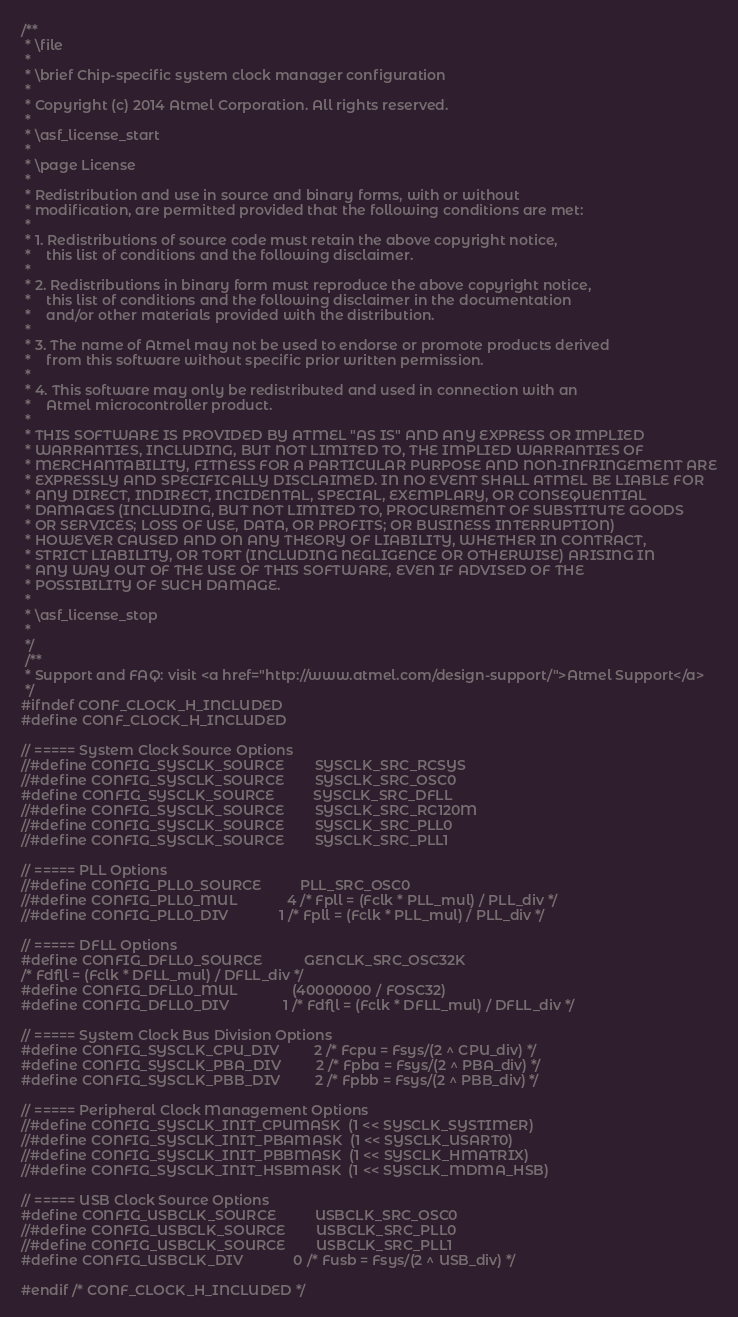<code> <loc_0><loc_0><loc_500><loc_500><_C_>/**
 * \file
 *
 * \brief Chip-specific system clock manager configuration
 *
 * Copyright (c) 2014 Atmel Corporation. All rights reserved.
 *
 * \asf_license_start
 *
 * \page License
 *
 * Redistribution and use in source and binary forms, with or without
 * modification, are permitted provided that the following conditions are met:
 *
 * 1. Redistributions of source code must retain the above copyright notice,
 *    this list of conditions and the following disclaimer.
 *
 * 2. Redistributions in binary form must reproduce the above copyright notice,
 *    this list of conditions and the following disclaimer in the documentation
 *    and/or other materials provided with the distribution.
 *
 * 3. The name of Atmel may not be used to endorse or promote products derived
 *    from this software without specific prior written permission.
 *
 * 4. This software may only be redistributed and used in connection with an
 *    Atmel microcontroller product.
 *
 * THIS SOFTWARE IS PROVIDED BY ATMEL "AS IS" AND ANY EXPRESS OR IMPLIED
 * WARRANTIES, INCLUDING, BUT NOT LIMITED TO, THE IMPLIED WARRANTIES OF
 * MERCHANTABILITY, FITNESS FOR A PARTICULAR PURPOSE AND NON-INFRINGEMENT ARE
 * EXPRESSLY AND SPECIFICALLY DISCLAIMED. IN NO EVENT SHALL ATMEL BE LIABLE FOR
 * ANY DIRECT, INDIRECT, INCIDENTAL, SPECIAL, EXEMPLARY, OR CONSEQUENTIAL
 * DAMAGES (INCLUDING, BUT NOT LIMITED TO, PROCUREMENT OF SUBSTITUTE GOODS
 * OR SERVICES; LOSS OF USE, DATA, OR PROFITS; OR BUSINESS INTERRUPTION)
 * HOWEVER CAUSED AND ON ANY THEORY OF LIABILITY, WHETHER IN CONTRACT,
 * STRICT LIABILITY, OR TORT (INCLUDING NEGLIGENCE OR OTHERWISE) ARISING IN
 * ANY WAY OUT OF THE USE OF THIS SOFTWARE, EVEN IF ADVISED OF THE
 * POSSIBILITY OF SUCH DAMAGE.
 *
 * \asf_license_stop
 *
 */
 /**
 * Support and FAQ: visit <a href="http://www.atmel.com/design-support/">Atmel Support</a>
 */
#ifndef CONF_CLOCK_H_INCLUDED
#define CONF_CLOCK_H_INCLUDED

// ===== System Clock Source Options
//#define CONFIG_SYSCLK_SOURCE        SYSCLK_SRC_RCSYS
//#define CONFIG_SYSCLK_SOURCE        SYSCLK_SRC_OSC0
#define CONFIG_SYSCLK_SOURCE          SYSCLK_SRC_DFLL
//#define CONFIG_SYSCLK_SOURCE        SYSCLK_SRC_RC120M
//#define CONFIG_SYSCLK_SOURCE        SYSCLK_SRC_PLL0
//#define CONFIG_SYSCLK_SOURCE        SYSCLK_SRC_PLL1

// ===== PLL Options
//#define CONFIG_PLL0_SOURCE          PLL_SRC_OSC0
//#define CONFIG_PLL0_MUL             4 /* Fpll = (Fclk * PLL_mul) / PLL_div */
//#define CONFIG_PLL0_DIV             1 /* Fpll = (Fclk * PLL_mul) / PLL_div */

// ===== DFLL Options
#define CONFIG_DFLL0_SOURCE           GENCLK_SRC_OSC32K
/* Fdfll = (Fclk * DFLL_mul) / DFLL_div */
#define CONFIG_DFLL0_MUL              (40000000 / FOSC32)
#define CONFIG_DFLL0_DIV              1 /* Fdfll = (Fclk * DFLL_mul) / DFLL_div */

// ===== System Clock Bus Division Options
#define CONFIG_SYSCLK_CPU_DIV         2 /* Fcpu = Fsys/(2 ^ CPU_div) */
#define CONFIG_SYSCLK_PBA_DIV         2 /* Fpba = Fsys/(2 ^ PBA_div) */
#define CONFIG_SYSCLK_PBB_DIV         2 /* Fpbb = Fsys/(2 ^ PBB_div) */

// ===== Peripheral Clock Management Options
//#define CONFIG_SYSCLK_INIT_CPUMASK  (1 << SYSCLK_SYSTIMER)
//#define CONFIG_SYSCLK_INIT_PBAMASK  (1 << SYSCLK_USART0)
//#define CONFIG_SYSCLK_INIT_PBBMASK  (1 << SYSCLK_HMATRIX)
//#define CONFIG_SYSCLK_INIT_HSBMASK  (1 << SYSCLK_MDMA_HSB)

// ===== USB Clock Source Options
#define CONFIG_USBCLK_SOURCE          USBCLK_SRC_OSC0
//#define CONFIG_USBCLK_SOURCE        USBCLK_SRC_PLL0
//#define CONFIG_USBCLK_SOURCE        USBCLK_SRC_PLL1
#define CONFIG_USBCLK_DIV             0 /* Fusb = Fsys/(2 ^ USB_div) */

#endif /* CONF_CLOCK_H_INCLUDED */
</code> 